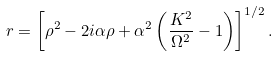<formula> <loc_0><loc_0><loc_500><loc_500>r = \left [ \rho ^ { 2 } - 2 i \alpha \rho + \alpha ^ { 2 } \left ( \frac { K ^ { 2 } } { \Omega ^ { 2 } } - 1 \right ) \right ] ^ { 1 / 2 } .</formula> 